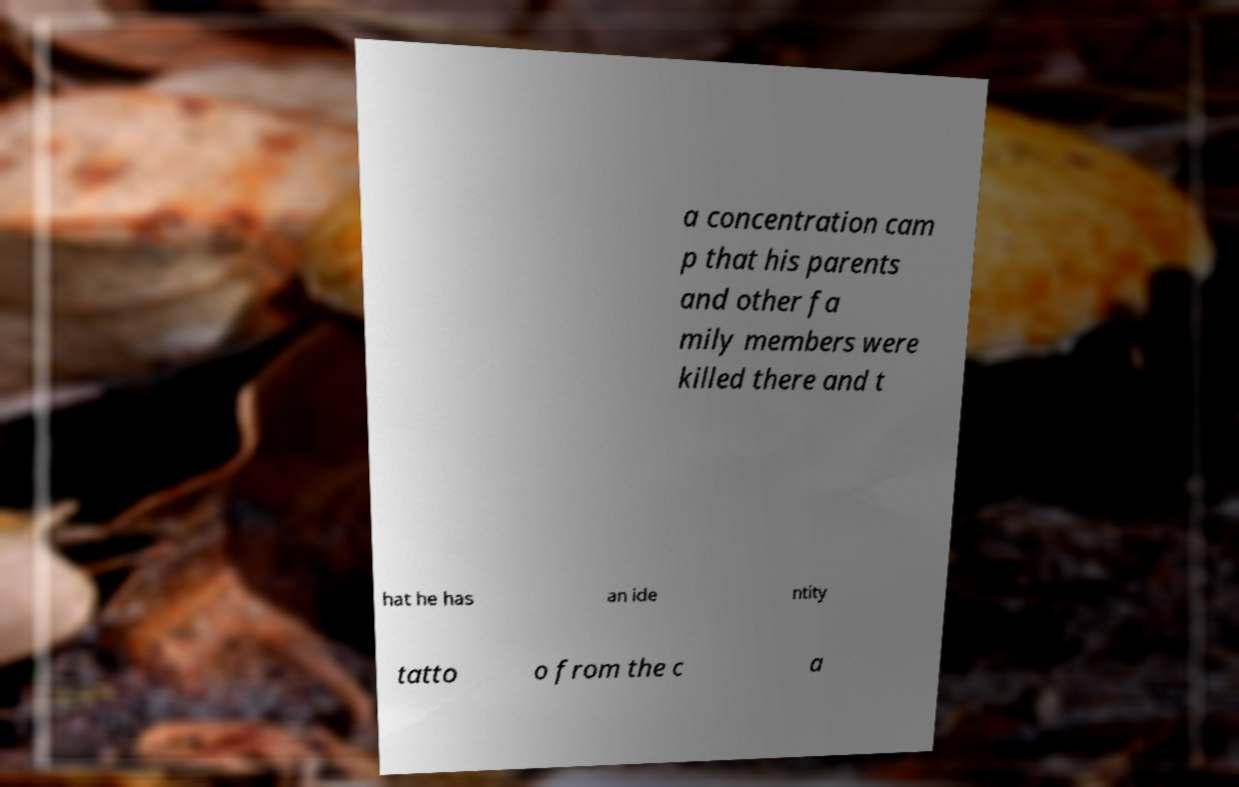I need the written content from this picture converted into text. Can you do that? a concentration cam p that his parents and other fa mily members were killed there and t hat he has an ide ntity tatto o from the c a 